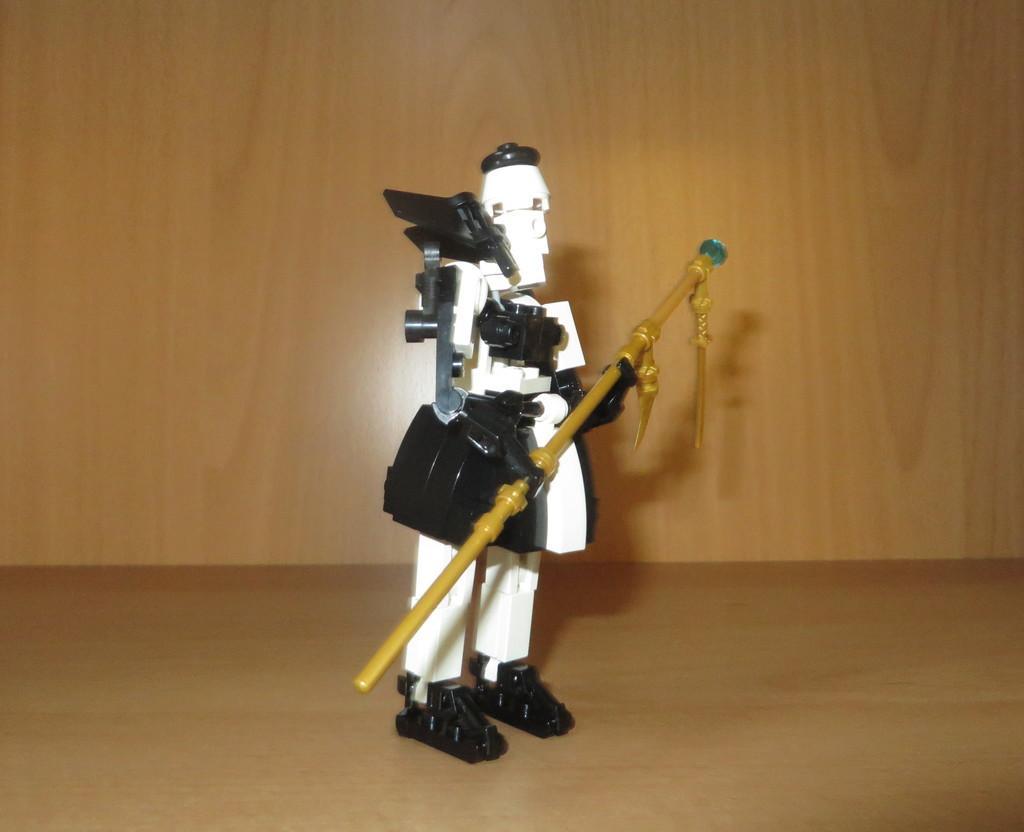How would you summarize this image in a sentence or two? In this picture we can see a toy on the surface and in the background we can see the wall. 